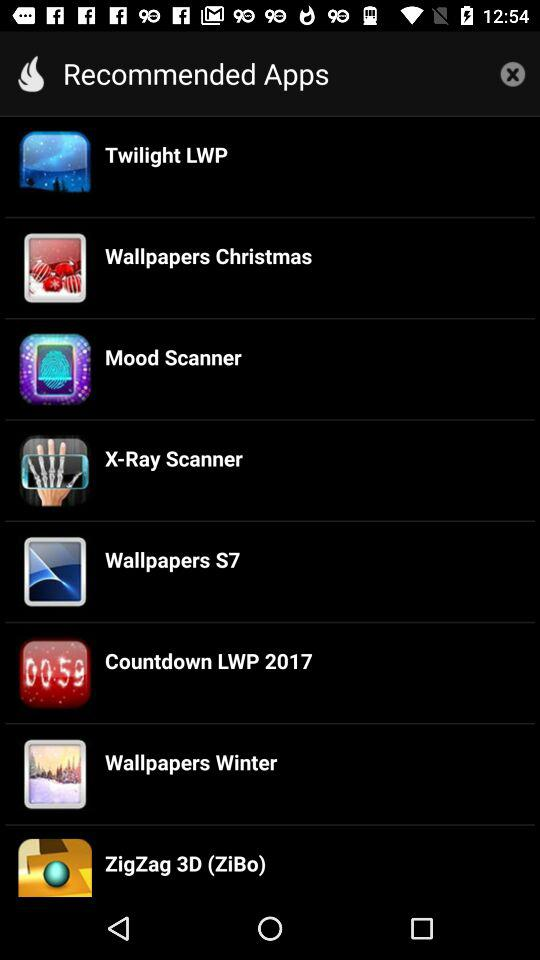What are the recommended applications? The recommended applications are "Twilight LWP", "Wallpapers Christmas", "Mood Scanner", "X-Ray Scanner", "Wallpapers S7", "Countdown LWP 2017", "Wallpapers Winter" and "ZigZag 3D (ZiBo)". 